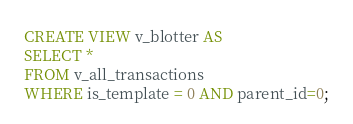<code> <loc_0><loc_0><loc_500><loc_500><_SQL_>CREATE VIEW v_blotter AS 
SELECT *
FROM v_all_transactions
WHERE is_template = 0 AND parent_id=0;</code> 